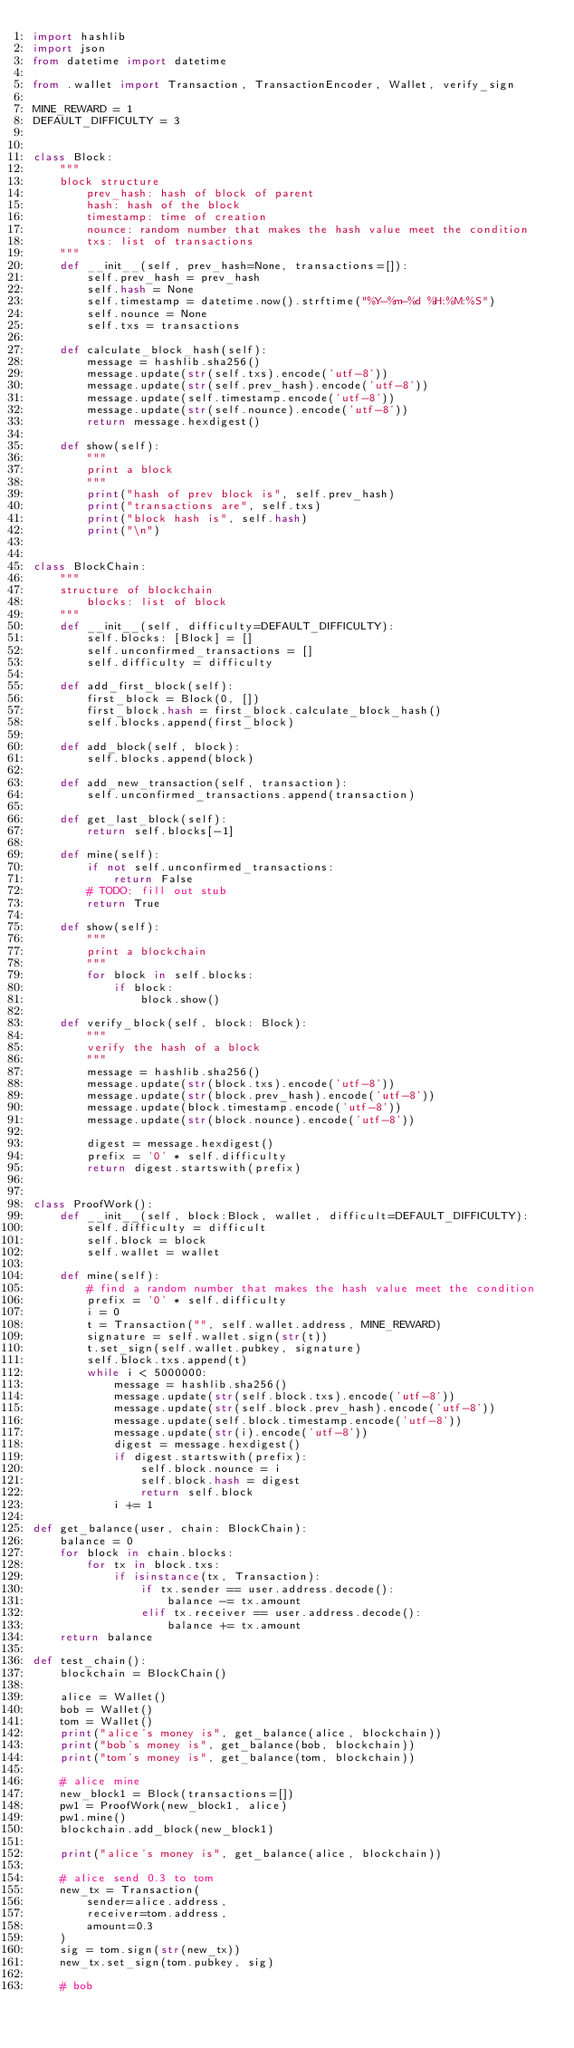Convert code to text. <code><loc_0><loc_0><loc_500><loc_500><_Python_>import hashlib
import json
from datetime import datetime

from .wallet import Transaction, TransactionEncoder, Wallet, verify_sign

MINE_REWARD = 1
DEFAULT_DIFFICULTY = 3


class Block:
    """
    block structure
        prev_hash: hash of block of parent
        hash: hash of the block
        timestamp: time of creation
        nounce: random number that makes the hash value meet the condition
        txs: list of transactions
    """
    def __init__(self, prev_hash=None, transactions=[]):
        self.prev_hash = prev_hash
        self.hash = None
        self.timestamp = datetime.now().strftime("%Y-%m-%d %H:%M:%S")
        self.nounce = None
        self.txs = transactions

    def calculate_block_hash(self):
        message = hashlib.sha256()
        message.update(str(self.txs).encode('utf-8'))
        message.update(str(self.prev_hash).encode('utf-8'))
        message.update(self.timestamp.encode('utf-8'))
        message.update(str(self.nounce).encode('utf-8'))
        return message.hexdigest()

    def show(self):
        """
        print a block
        """
        print("hash of prev block is", self.prev_hash)
        print("transactions are", self.txs)
        print("block hash is", self.hash)
        print("\n")


class BlockChain:
    """
    structure of blockchain
        blocks: list of block
    """
    def __init__(self, difficulty=DEFAULT_DIFFICULTY):
        self.blocks: [Block] = []
        self.unconfirmed_transactions = []
        self.difficulty = difficulty

    def add_first_block(self):
        first_block = Block(0, [])
        first_block.hash = first_block.calculate_block_hash()
        self.blocks.append(first_block)

    def add_block(self, block):
        self.blocks.append(block)

    def add_new_transaction(self, transaction):
        self.unconfirmed_transactions.append(transaction)

    def get_last_block(self):
        return self.blocks[-1]

    def mine(self):
        if not self.unconfirmed_transactions:
            return False
        # TODO: fill out stub
        return True

    def show(self):
        """
        print a blockchain
        """
        for block in self.blocks:
            if block:
                block.show()

    def verify_block(self, block: Block):
        """
        verify the hash of a block
        """
        message = hashlib.sha256()
        message.update(str(block.txs).encode('utf-8'))
        message.update(str(block.prev_hash).encode('utf-8'))
        message.update(block.timestamp.encode('utf-8'))
        message.update(str(block.nounce).encode('utf-8'))

        digest = message.hexdigest()
        prefix = '0' * self.difficulty
        return digest.startswith(prefix)


class ProofWork():
    def __init__(self, block:Block, wallet, difficult=DEFAULT_DIFFICULTY):
        self.difficulty = difficult
        self.block = block
        self.wallet = wallet

    def mine(self):
        # find a random number that makes the hash value meet the condition
        prefix = '0' * self.difficulty
        i = 0
        t = Transaction("", self.wallet.address, MINE_REWARD)
        signature = self.wallet.sign(str(t))
        t.set_sign(self.wallet.pubkey, signature)
        self.block.txs.append(t)
        while i < 5000000:
            message = hashlib.sha256()
            message.update(str(self.block.txs).encode('utf-8'))
            message.update(str(self.block.prev_hash).encode('utf-8'))
            message.update(self.block.timestamp.encode('utf-8'))
            message.update(str(i).encode('utf-8'))
            digest = message.hexdigest()
            if digest.startswith(prefix):
                self.block.nounce = i
                self.block.hash = digest
                return self.block
            i += 1

def get_balance(user, chain: BlockChain):
    balance = 0
    for block in chain.blocks:
        for tx in block.txs:
            if isinstance(tx, Transaction):
                if tx.sender == user.address.decode():
                    balance -= tx.amount
                elif tx.receiver == user.address.decode():
                    balance += tx.amount
    return balance

def test_chain():
    blockchain = BlockChain()

    alice = Wallet()
    bob = Wallet()
    tom = Wallet()
    print("alice's money is", get_balance(alice, blockchain))
    print("bob's money is", get_balance(bob, blockchain))
    print("tom's money is", get_balance(tom, blockchain))

    # alice mine
    new_block1 = Block(transactions=[])
    pw1 = ProofWork(new_block1, alice)
    pw1.mine()
    blockchain.add_block(new_block1)

    print("alice's money is", get_balance(alice, blockchain))

    # alice send 0.3 to tom
    new_tx = Transaction(
        sender=alice.address,
        receiver=tom.address,
        amount=0.3
    )
    sig = tom.sign(str(new_tx))
    new_tx.set_sign(tom.pubkey, sig)

    # bob</code> 